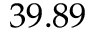<formula> <loc_0><loc_0><loc_500><loc_500>3 9 . 8 9</formula> 